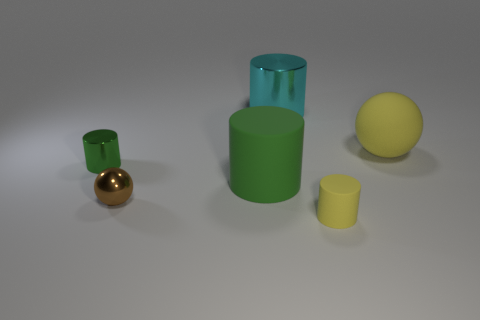Subtract all tiny green cylinders. How many cylinders are left? 3 Subtract all red spheres. How many green cylinders are left? 2 Subtract 1 cylinders. How many cylinders are left? 3 Subtract all yellow cylinders. How many cylinders are left? 3 Add 1 yellow cylinders. How many objects exist? 7 Subtract all red cylinders. Subtract all purple spheres. How many cylinders are left? 4 Subtract all balls. How many objects are left? 4 Subtract all brown cylinders. Subtract all large yellow matte things. How many objects are left? 5 Add 3 small yellow objects. How many small yellow objects are left? 4 Add 5 tiny blue rubber cylinders. How many tiny blue rubber cylinders exist? 5 